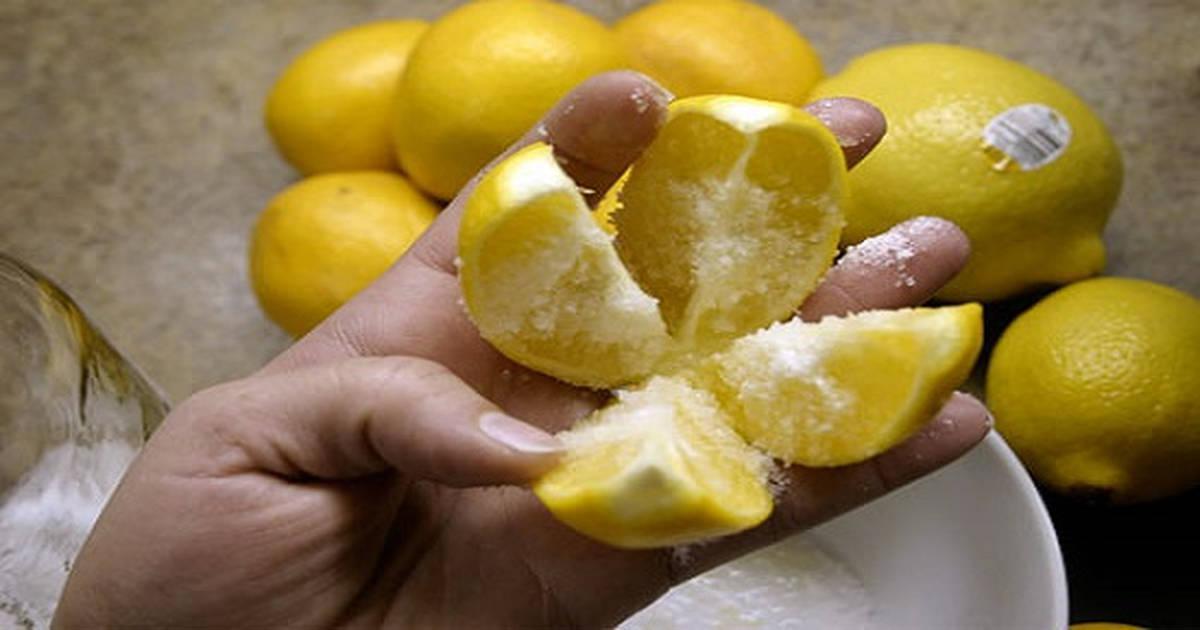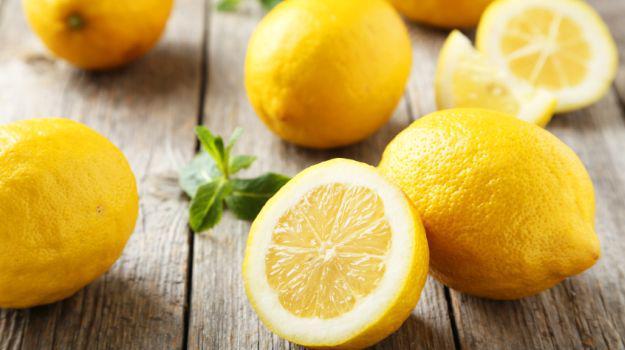The first image is the image on the left, the second image is the image on the right. Evaluate the accuracy of this statement regarding the images: "The right image shows a lemon cross cut into four parts with salt poured on it.". Is it true? Answer yes or no. No. The first image is the image on the left, the second image is the image on the right. For the images shown, is this caption "In one of the images, there is salt next to the lemons but not on any of them." true? Answer yes or no. No. 